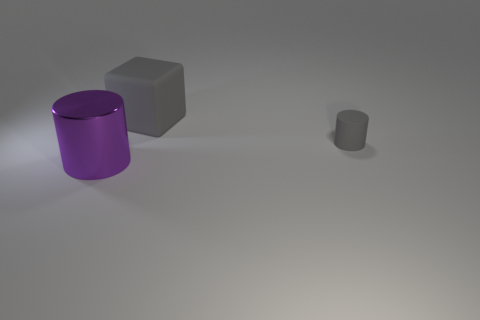Add 1 matte cylinders. How many objects exist? 4 Subtract all gray cylinders. How many cylinders are left? 1 Subtract all brown cubes. Subtract all green cylinders. How many cubes are left? 1 Subtract all cyan cylinders. How many purple cubes are left? 0 Subtract all rubber blocks. Subtract all rubber cubes. How many objects are left? 1 Add 1 large objects. How many large objects are left? 3 Add 1 small cyan rubber cylinders. How many small cyan rubber cylinders exist? 1 Subtract 0 green spheres. How many objects are left? 3 Subtract all cylinders. How many objects are left? 1 